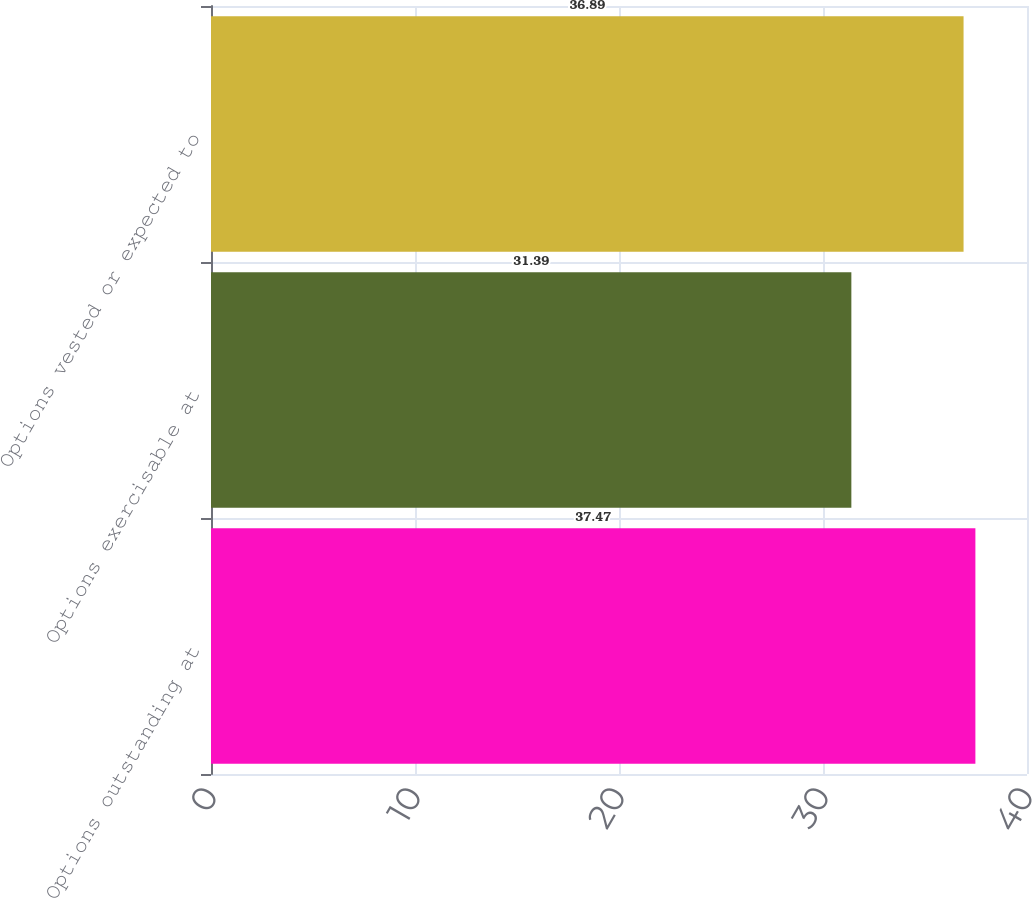Convert chart to OTSL. <chart><loc_0><loc_0><loc_500><loc_500><bar_chart><fcel>Options outstanding at<fcel>Options exercisable at<fcel>Options vested or expected to<nl><fcel>37.47<fcel>31.39<fcel>36.89<nl></chart> 